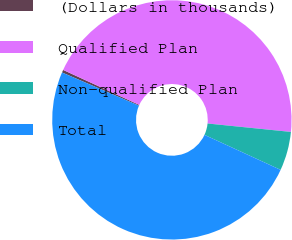Convert chart to OTSL. <chart><loc_0><loc_0><loc_500><loc_500><pie_chart><fcel>(Dollars in thousands)<fcel>Qualified Plan<fcel>Non-qualified Plan<fcel>Total<nl><fcel>0.37%<fcel>44.75%<fcel>5.25%<fcel>49.63%<nl></chart> 